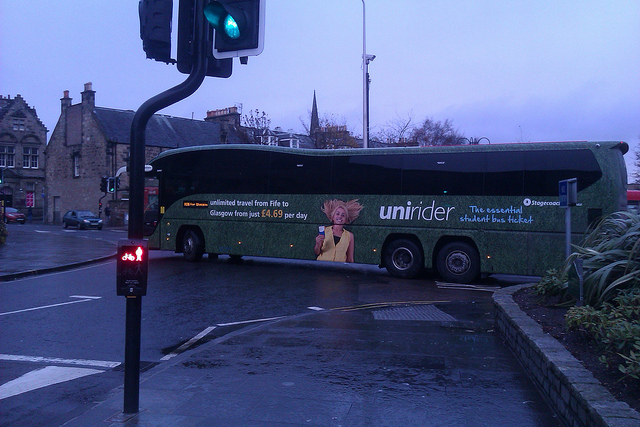Given the visual context, what might be the primary purpose of the bus? Considering the promotional details displayed on the bus, its primary purpose is to offer a transportation service aimed at students. This service provides unlimited travel between Fife and Glasgow at an affordable daily rate, ideal for a student demographic. 